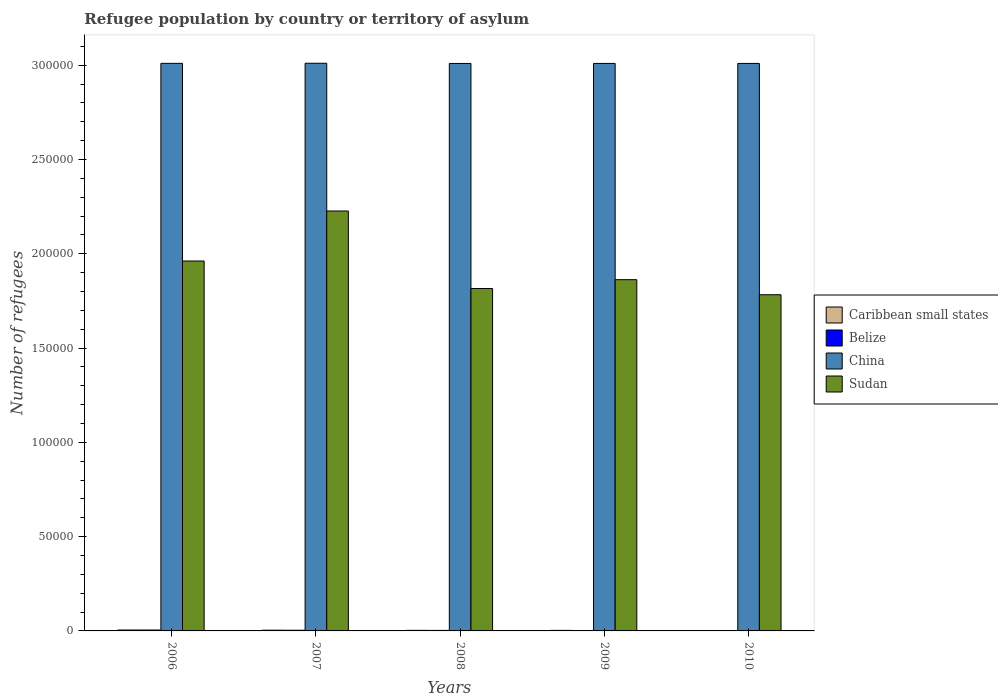How many different coloured bars are there?
Offer a very short reply. 4. Are the number of bars per tick equal to the number of legend labels?
Provide a succinct answer. Yes. Are the number of bars on each tick of the X-axis equal?
Give a very brief answer. Yes. How many bars are there on the 5th tick from the left?
Provide a succinct answer. 4. What is the number of refugees in China in 2006?
Your answer should be compact. 3.01e+05. Across all years, what is the maximum number of refugees in Caribbean small states?
Your answer should be compact. 488. Across all years, what is the minimum number of refugees in Belize?
Offer a very short reply. 134. In which year was the number of refugees in Belize maximum?
Ensure brevity in your answer.  2006. In which year was the number of refugees in China minimum?
Provide a short and direct response. 2008. What is the total number of refugees in China in the graph?
Provide a succinct answer. 1.51e+06. What is the difference between the number of refugees in Caribbean small states in 2007 and that in 2010?
Provide a short and direct response. 161. What is the difference between the number of refugees in China in 2009 and the number of refugees in Belize in 2006?
Offer a very short reply. 3.01e+05. What is the average number of refugees in China per year?
Provide a succinct answer. 3.01e+05. In the year 2006, what is the difference between the number of refugees in Belize and number of refugees in Sudan?
Your answer should be compact. -1.96e+05. In how many years, is the number of refugees in China greater than 290000?
Your answer should be very brief. 5. What is the ratio of the number of refugees in Belize in 2006 to that in 2010?
Give a very brief answer. 3.64. Is the number of refugees in China in 2006 less than that in 2010?
Your answer should be compact. No. What is the difference between the highest and the lowest number of refugees in Caribbean small states?
Your answer should be very brief. 268. Is it the case that in every year, the sum of the number of refugees in China and number of refugees in Caribbean small states is greater than the sum of number of refugees in Belize and number of refugees in Sudan?
Provide a short and direct response. No. What does the 2nd bar from the left in 2010 represents?
Provide a short and direct response. Belize. What does the 4th bar from the right in 2007 represents?
Keep it short and to the point. Caribbean small states. How many bars are there?
Give a very brief answer. 20. Are all the bars in the graph horizontal?
Your response must be concise. No. Does the graph contain grids?
Provide a succinct answer. No. Where does the legend appear in the graph?
Make the answer very short. Center right. How many legend labels are there?
Offer a terse response. 4. How are the legend labels stacked?
Offer a terse response. Vertical. What is the title of the graph?
Make the answer very short. Refugee population by country or territory of asylum. What is the label or title of the Y-axis?
Your answer should be compact. Number of refugees. What is the Number of refugees of Caribbean small states in 2006?
Ensure brevity in your answer.  488. What is the Number of refugees in Belize in 2006?
Offer a terse response. 488. What is the Number of refugees in China in 2006?
Offer a very short reply. 3.01e+05. What is the Number of refugees in Sudan in 2006?
Your answer should be very brief. 1.96e+05. What is the Number of refugees of Caribbean small states in 2007?
Offer a very short reply. 381. What is the Number of refugees of Belize in 2007?
Offer a terse response. 358. What is the Number of refugees in China in 2007?
Your response must be concise. 3.01e+05. What is the Number of refugees in Sudan in 2007?
Offer a terse response. 2.23e+05. What is the Number of refugees of Caribbean small states in 2008?
Keep it short and to the point. 311. What is the Number of refugees of Belize in 2008?
Your answer should be very brief. 277. What is the Number of refugees in China in 2008?
Offer a very short reply. 3.01e+05. What is the Number of refugees of Sudan in 2008?
Your answer should be very brief. 1.82e+05. What is the Number of refugees of Caribbean small states in 2009?
Ensure brevity in your answer.  294. What is the Number of refugees in Belize in 2009?
Provide a short and direct response. 230. What is the Number of refugees of China in 2009?
Your answer should be very brief. 3.01e+05. What is the Number of refugees of Sudan in 2009?
Keep it short and to the point. 1.86e+05. What is the Number of refugees in Caribbean small states in 2010?
Provide a succinct answer. 220. What is the Number of refugees of Belize in 2010?
Offer a terse response. 134. What is the Number of refugees in China in 2010?
Your answer should be compact. 3.01e+05. What is the Number of refugees of Sudan in 2010?
Give a very brief answer. 1.78e+05. Across all years, what is the maximum Number of refugees in Caribbean small states?
Your answer should be compact. 488. Across all years, what is the maximum Number of refugees in Belize?
Give a very brief answer. 488. Across all years, what is the maximum Number of refugees in China?
Provide a short and direct response. 3.01e+05. Across all years, what is the maximum Number of refugees in Sudan?
Provide a short and direct response. 2.23e+05. Across all years, what is the minimum Number of refugees in Caribbean small states?
Keep it short and to the point. 220. Across all years, what is the minimum Number of refugees of Belize?
Your response must be concise. 134. Across all years, what is the minimum Number of refugees in China?
Provide a succinct answer. 3.01e+05. Across all years, what is the minimum Number of refugees of Sudan?
Provide a short and direct response. 1.78e+05. What is the total Number of refugees in Caribbean small states in the graph?
Offer a terse response. 1694. What is the total Number of refugees in Belize in the graph?
Your answer should be very brief. 1487. What is the total Number of refugees of China in the graph?
Give a very brief answer. 1.51e+06. What is the total Number of refugees in Sudan in the graph?
Your answer should be very brief. 9.65e+05. What is the difference between the Number of refugees of Caribbean small states in 2006 and that in 2007?
Make the answer very short. 107. What is the difference between the Number of refugees in Belize in 2006 and that in 2007?
Provide a short and direct response. 130. What is the difference between the Number of refugees of China in 2006 and that in 2007?
Make the answer very short. -51. What is the difference between the Number of refugees of Sudan in 2006 and that in 2007?
Keep it short and to the point. -2.65e+04. What is the difference between the Number of refugees of Caribbean small states in 2006 and that in 2008?
Offer a terse response. 177. What is the difference between the Number of refugees in Belize in 2006 and that in 2008?
Offer a very short reply. 211. What is the difference between the Number of refugees in China in 2006 and that in 2008?
Provide a succinct answer. 60. What is the difference between the Number of refugees of Sudan in 2006 and that in 2008?
Provide a short and direct response. 1.46e+04. What is the difference between the Number of refugees in Caribbean small states in 2006 and that in 2009?
Provide a succinct answer. 194. What is the difference between the Number of refugees of Belize in 2006 and that in 2009?
Offer a terse response. 258. What is the difference between the Number of refugees in Sudan in 2006 and that in 2009?
Provide a succinct answer. 9908. What is the difference between the Number of refugees of Caribbean small states in 2006 and that in 2010?
Provide a succinct answer. 268. What is the difference between the Number of refugees of Belize in 2006 and that in 2010?
Make the answer very short. 354. What is the difference between the Number of refugees of Sudan in 2006 and that in 2010?
Keep it short and to the point. 1.79e+04. What is the difference between the Number of refugees in Caribbean small states in 2007 and that in 2008?
Offer a very short reply. 70. What is the difference between the Number of refugees of Belize in 2007 and that in 2008?
Give a very brief answer. 81. What is the difference between the Number of refugees in China in 2007 and that in 2008?
Your response must be concise. 111. What is the difference between the Number of refugees in Sudan in 2007 and that in 2008?
Provide a succinct answer. 4.11e+04. What is the difference between the Number of refugees of Caribbean small states in 2007 and that in 2009?
Offer a very short reply. 87. What is the difference between the Number of refugees of Belize in 2007 and that in 2009?
Provide a short and direct response. 128. What is the difference between the Number of refugees of China in 2007 and that in 2009?
Your answer should be compact. 89. What is the difference between the Number of refugees of Sudan in 2007 and that in 2009?
Keep it short and to the point. 3.64e+04. What is the difference between the Number of refugees of Caribbean small states in 2007 and that in 2010?
Offer a terse response. 161. What is the difference between the Number of refugees of Belize in 2007 and that in 2010?
Your answer should be very brief. 224. What is the difference between the Number of refugees of China in 2007 and that in 2010?
Your answer should be compact. 92. What is the difference between the Number of refugees in Sudan in 2007 and that in 2010?
Make the answer very short. 4.44e+04. What is the difference between the Number of refugees in Belize in 2008 and that in 2009?
Your answer should be compact. 47. What is the difference between the Number of refugees in China in 2008 and that in 2009?
Provide a succinct answer. -22. What is the difference between the Number of refugees of Sudan in 2008 and that in 2009?
Ensure brevity in your answer.  -4687. What is the difference between the Number of refugees in Caribbean small states in 2008 and that in 2010?
Offer a terse response. 91. What is the difference between the Number of refugees of Belize in 2008 and that in 2010?
Give a very brief answer. 143. What is the difference between the Number of refugees in Sudan in 2008 and that in 2010?
Your response must be concise. 3297. What is the difference between the Number of refugees of Belize in 2009 and that in 2010?
Offer a terse response. 96. What is the difference between the Number of refugees of Sudan in 2009 and that in 2010?
Offer a terse response. 7984. What is the difference between the Number of refugees of Caribbean small states in 2006 and the Number of refugees of Belize in 2007?
Provide a short and direct response. 130. What is the difference between the Number of refugees in Caribbean small states in 2006 and the Number of refugees in China in 2007?
Your answer should be compact. -3.01e+05. What is the difference between the Number of refugees of Caribbean small states in 2006 and the Number of refugees of Sudan in 2007?
Your response must be concise. -2.22e+05. What is the difference between the Number of refugees of Belize in 2006 and the Number of refugees of China in 2007?
Keep it short and to the point. -3.01e+05. What is the difference between the Number of refugees in Belize in 2006 and the Number of refugees in Sudan in 2007?
Your answer should be compact. -2.22e+05. What is the difference between the Number of refugees of China in 2006 and the Number of refugees of Sudan in 2007?
Your answer should be compact. 7.83e+04. What is the difference between the Number of refugees in Caribbean small states in 2006 and the Number of refugees in Belize in 2008?
Keep it short and to the point. 211. What is the difference between the Number of refugees in Caribbean small states in 2006 and the Number of refugees in China in 2008?
Ensure brevity in your answer.  -3.00e+05. What is the difference between the Number of refugees in Caribbean small states in 2006 and the Number of refugees in Sudan in 2008?
Ensure brevity in your answer.  -1.81e+05. What is the difference between the Number of refugees in Belize in 2006 and the Number of refugees in China in 2008?
Your response must be concise. -3.00e+05. What is the difference between the Number of refugees of Belize in 2006 and the Number of refugees of Sudan in 2008?
Keep it short and to the point. -1.81e+05. What is the difference between the Number of refugees of China in 2006 and the Number of refugees of Sudan in 2008?
Offer a terse response. 1.19e+05. What is the difference between the Number of refugees of Caribbean small states in 2006 and the Number of refugees of Belize in 2009?
Offer a terse response. 258. What is the difference between the Number of refugees in Caribbean small states in 2006 and the Number of refugees in China in 2009?
Your answer should be compact. -3.01e+05. What is the difference between the Number of refugees of Caribbean small states in 2006 and the Number of refugees of Sudan in 2009?
Ensure brevity in your answer.  -1.86e+05. What is the difference between the Number of refugees in Belize in 2006 and the Number of refugees in China in 2009?
Your answer should be very brief. -3.01e+05. What is the difference between the Number of refugees of Belize in 2006 and the Number of refugees of Sudan in 2009?
Ensure brevity in your answer.  -1.86e+05. What is the difference between the Number of refugees of China in 2006 and the Number of refugees of Sudan in 2009?
Your answer should be compact. 1.15e+05. What is the difference between the Number of refugees in Caribbean small states in 2006 and the Number of refugees in Belize in 2010?
Provide a succinct answer. 354. What is the difference between the Number of refugees in Caribbean small states in 2006 and the Number of refugees in China in 2010?
Ensure brevity in your answer.  -3.00e+05. What is the difference between the Number of refugees in Caribbean small states in 2006 and the Number of refugees in Sudan in 2010?
Keep it short and to the point. -1.78e+05. What is the difference between the Number of refugees of Belize in 2006 and the Number of refugees of China in 2010?
Offer a very short reply. -3.00e+05. What is the difference between the Number of refugees in Belize in 2006 and the Number of refugees in Sudan in 2010?
Keep it short and to the point. -1.78e+05. What is the difference between the Number of refugees of China in 2006 and the Number of refugees of Sudan in 2010?
Ensure brevity in your answer.  1.23e+05. What is the difference between the Number of refugees of Caribbean small states in 2007 and the Number of refugees of Belize in 2008?
Provide a short and direct response. 104. What is the difference between the Number of refugees in Caribbean small states in 2007 and the Number of refugees in China in 2008?
Your answer should be very brief. -3.01e+05. What is the difference between the Number of refugees in Caribbean small states in 2007 and the Number of refugees in Sudan in 2008?
Offer a terse response. -1.81e+05. What is the difference between the Number of refugees of Belize in 2007 and the Number of refugees of China in 2008?
Your answer should be compact. -3.01e+05. What is the difference between the Number of refugees of Belize in 2007 and the Number of refugees of Sudan in 2008?
Your answer should be very brief. -1.81e+05. What is the difference between the Number of refugees in China in 2007 and the Number of refugees in Sudan in 2008?
Your answer should be compact. 1.19e+05. What is the difference between the Number of refugees in Caribbean small states in 2007 and the Number of refugees in Belize in 2009?
Give a very brief answer. 151. What is the difference between the Number of refugees in Caribbean small states in 2007 and the Number of refugees in China in 2009?
Ensure brevity in your answer.  -3.01e+05. What is the difference between the Number of refugees of Caribbean small states in 2007 and the Number of refugees of Sudan in 2009?
Provide a succinct answer. -1.86e+05. What is the difference between the Number of refugees in Belize in 2007 and the Number of refugees in China in 2009?
Your answer should be very brief. -3.01e+05. What is the difference between the Number of refugees of Belize in 2007 and the Number of refugees of Sudan in 2009?
Provide a succinct answer. -1.86e+05. What is the difference between the Number of refugees in China in 2007 and the Number of refugees in Sudan in 2009?
Offer a very short reply. 1.15e+05. What is the difference between the Number of refugees of Caribbean small states in 2007 and the Number of refugees of Belize in 2010?
Offer a very short reply. 247. What is the difference between the Number of refugees in Caribbean small states in 2007 and the Number of refugees in China in 2010?
Provide a short and direct response. -3.01e+05. What is the difference between the Number of refugees in Caribbean small states in 2007 and the Number of refugees in Sudan in 2010?
Offer a terse response. -1.78e+05. What is the difference between the Number of refugees in Belize in 2007 and the Number of refugees in China in 2010?
Provide a short and direct response. -3.01e+05. What is the difference between the Number of refugees in Belize in 2007 and the Number of refugees in Sudan in 2010?
Give a very brief answer. -1.78e+05. What is the difference between the Number of refugees in China in 2007 and the Number of refugees in Sudan in 2010?
Give a very brief answer. 1.23e+05. What is the difference between the Number of refugees in Caribbean small states in 2008 and the Number of refugees in China in 2009?
Make the answer very short. -3.01e+05. What is the difference between the Number of refugees in Caribbean small states in 2008 and the Number of refugees in Sudan in 2009?
Offer a very short reply. -1.86e+05. What is the difference between the Number of refugees in Belize in 2008 and the Number of refugees in China in 2009?
Give a very brief answer. -3.01e+05. What is the difference between the Number of refugees of Belize in 2008 and the Number of refugees of Sudan in 2009?
Ensure brevity in your answer.  -1.86e+05. What is the difference between the Number of refugees in China in 2008 and the Number of refugees in Sudan in 2009?
Your answer should be very brief. 1.15e+05. What is the difference between the Number of refugees of Caribbean small states in 2008 and the Number of refugees of Belize in 2010?
Your response must be concise. 177. What is the difference between the Number of refugees of Caribbean small states in 2008 and the Number of refugees of China in 2010?
Provide a succinct answer. -3.01e+05. What is the difference between the Number of refugees in Caribbean small states in 2008 and the Number of refugees in Sudan in 2010?
Offer a terse response. -1.78e+05. What is the difference between the Number of refugees of Belize in 2008 and the Number of refugees of China in 2010?
Your answer should be compact. -3.01e+05. What is the difference between the Number of refugees of Belize in 2008 and the Number of refugees of Sudan in 2010?
Your answer should be very brief. -1.78e+05. What is the difference between the Number of refugees in China in 2008 and the Number of refugees in Sudan in 2010?
Offer a terse response. 1.23e+05. What is the difference between the Number of refugees in Caribbean small states in 2009 and the Number of refugees in Belize in 2010?
Provide a succinct answer. 160. What is the difference between the Number of refugees in Caribbean small states in 2009 and the Number of refugees in China in 2010?
Give a very brief answer. -3.01e+05. What is the difference between the Number of refugees in Caribbean small states in 2009 and the Number of refugees in Sudan in 2010?
Provide a short and direct response. -1.78e+05. What is the difference between the Number of refugees in Belize in 2009 and the Number of refugees in China in 2010?
Give a very brief answer. -3.01e+05. What is the difference between the Number of refugees of Belize in 2009 and the Number of refugees of Sudan in 2010?
Make the answer very short. -1.78e+05. What is the difference between the Number of refugees in China in 2009 and the Number of refugees in Sudan in 2010?
Provide a succinct answer. 1.23e+05. What is the average Number of refugees in Caribbean small states per year?
Make the answer very short. 338.8. What is the average Number of refugees in Belize per year?
Ensure brevity in your answer.  297.4. What is the average Number of refugees of China per year?
Give a very brief answer. 3.01e+05. What is the average Number of refugees in Sudan per year?
Your answer should be compact. 1.93e+05. In the year 2006, what is the difference between the Number of refugees of Caribbean small states and Number of refugees of China?
Provide a short and direct response. -3.01e+05. In the year 2006, what is the difference between the Number of refugees of Caribbean small states and Number of refugees of Sudan?
Keep it short and to the point. -1.96e+05. In the year 2006, what is the difference between the Number of refugees of Belize and Number of refugees of China?
Make the answer very short. -3.01e+05. In the year 2006, what is the difference between the Number of refugees in Belize and Number of refugees in Sudan?
Provide a succinct answer. -1.96e+05. In the year 2006, what is the difference between the Number of refugees in China and Number of refugees in Sudan?
Offer a very short reply. 1.05e+05. In the year 2007, what is the difference between the Number of refugees in Caribbean small states and Number of refugees in Belize?
Your answer should be very brief. 23. In the year 2007, what is the difference between the Number of refugees in Caribbean small states and Number of refugees in China?
Keep it short and to the point. -3.01e+05. In the year 2007, what is the difference between the Number of refugees of Caribbean small states and Number of refugees of Sudan?
Make the answer very short. -2.22e+05. In the year 2007, what is the difference between the Number of refugees of Belize and Number of refugees of China?
Your response must be concise. -3.01e+05. In the year 2007, what is the difference between the Number of refugees in Belize and Number of refugees in Sudan?
Your answer should be compact. -2.22e+05. In the year 2007, what is the difference between the Number of refugees of China and Number of refugees of Sudan?
Provide a short and direct response. 7.84e+04. In the year 2008, what is the difference between the Number of refugees in Caribbean small states and Number of refugees in Belize?
Keep it short and to the point. 34. In the year 2008, what is the difference between the Number of refugees in Caribbean small states and Number of refugees in China?
Your response must be concise. -3.01e+05. In the year 2008, what is the difference between the Number of refugees of Caribbean small states and Number of refugees of Sudan?
Provide a short and direct response. -1.81e+05. In the year 2008, what is the difference between the Number of refugees in Belize and Number of refugees in China?
Your answer should be very brief. -3.01e+05. In the year 2008, what is the difference between the Number of refugees in Belize and Number of refugees in Sudan?
Keep it short and to the point. -1.81e+05. In the year 2008, what is the difference between the Number of refugees of China and Number of refugees of Sudan?
Give a very brief answer. 1.19e+05. In the year 2009, what is the difference between the Number of refugees of Caribbean small states and Number of refugees of Belize?
Your answer should be compact. 64. In the year 2009, what is the difference between the Number of refugees in Caribbean small states and Number of refugees in China?
Offer a terse response. -3.01e+05. In the year 2009, what is the difference between the Number of refugees of Caribbean small states and Number of refugees of Sudan?
Provide a succinct answer. -1.86e+05. In the year 2009, what is the difference between the Number of refugees in Belize and Number of refugees in China?
Your answer should be compact. -3.01e+05. In the year 2009, what is the difference between the Number of refugees in Belize and Number of refugees in Sudan?
Your answer should be compact. -1.86e+05. In the year 2009, what is the difference between the Number of refugees of China and Number of refugees of Sudan?
Your response must be concise. 1.15e+05. In the year 2010, what is the difference between the Number of refugees in Caribbean small states and Number of refugees in Belize?
Give a very brief answer. 86. In the year 2010, what is the difference between the Number of refugees of Caribbean small states and Number of refugees of China?
Provide a succinct answer. -3.01e+05. In the year 2010, what is the difference between the Number of refugees in Caribbean small states and Number of refugees in Sudan?
Offer a very short reply. -1.78e+05. In the year 2010, what is the difference between the Number of refugees in Belize and Number of refugees in China?
Ensure brevity in your answer.  -3.01e+05. In the year 2010, what is the difference between the Number of refugees of Belize and Number of refugees of Sudan?
Offer a terse response. -1.78e+05. In the year 2010, what is the difference between the Number of refugees in China and Number of refugees in Sudan?
Give a very brief answer. 1.23e+05. What is the ratio of the Number of refugees in Caribbean small states in 2006 to that in 2007?
Offer a terse response. 1.28. What is the ratio of the Number of refugees in Belize in 2006 to that in 2007?
Your answer should be very brief. 1.36. What is the ratio of the Number of refugees of China in 2006 to that in 2007?
Ensure brevity in your answer.  1. What is the ratio of the Number of refugees of Sudan in 2006 to that in 2007?
Keep it short and to the point. 0.88. What is the ratio of the Number of refugees of Caribbean small states in 2006 to that in 2008?
Provide a succinct answer. 1.57. What is the ratio of the Number of refugees in Belize in 2006 to that in 2008?
Ensure brevity in your answer.  1.76. What is the ratio of the Number of refugees of China in 2006 to that in 2008?
Offer a terse response. 1. What is the ratio of the Number of refugees of Sudan in 2006 to that in 2008?
Ensure brevity in your answer.  1.08. What is the ratio of the Number of refugees of Caribbean small states in 2006 to that in 2009?
Make the answer very short. 1.66. What is the ratio of the Number of refugees of Belize in 2006 to that in 2009?
Give a very brief answer. 2.12. What is the ratio of the Number of refugees in Sudan in 2006 to that in 2009?
Keep it short and to the point. 1.05. What is the ratio of the Number of refugees of Caribbean small states in 2006 to that in 2010?
Keep it short and to the point. 2.22. What is the ratio of the Number of refugees of Belize in 2006 to that in 2010?
Provide a succinct answer. 3.64. What is the ratio of the Number of refugees of Sudan in 2006 to that in 2010?
Provide a succinct answer. 1.1. What is the ratio of the Number of refugees of Caribbean small states in 2007 to that in 2008?
Offer a terse response. 1.23. What is the ratio of the Number of refugees of Belize in 2007 to that in 2008?
Your answer should be compact. 1.29. What is the ratio of the Number of refugees of China in 2007 to that in 2008?
Offer a terse response. 1. What is the ratio of the Number of refugees in Sudan in 2007 to that in 2008?
Offer a terse response. 1.23. What is the ratio of the Number of refugees in Caribbean small states in 2007 to that in 2009?
Provide a succinct answer. 1.3. What is the ratio of the Number of refugees of Belize in 2007 to that in 2009?
Keep it short and to the point. 1.56. What is the ratio of the Number of refugees in China in 2007 to that in 2009?
Keep it short and to the point. 1. What is the ratio of the Number of refugees in Sudan in 2007 to that in 2009?
Give a very brief answer. 1.2. What is the ratio of the Number of refugees of Caribbean small states in 2007 to that in 2010?
Offer a very short reply. 1.73. What is the ratio of the Number of refugees of Belize in 2007 to that in 2010?
Offer a terse response. 2.67. What is the ratio of the Number of refugees in China in 2007 to that in 2010?
Give a very brief answer. 1. What is the ratio of the Number of refugees in Sudan in 2007 to that in 2010?
Your answer should be very brief. 1.25. What is the ratio of the Number of refugees in Caribbean small states in 2008 to that in 2009?
Your answer should be very brief. 1.06. What is the ratio of the Number of refugees in Belize in 2008 to that in 2009?
Provide a short and direct response. 1.2. What is the ratio of the Number of refugees of China in 2008 to that in 2009?
Your response must be concise. 1. What is the ratio of the Number of refugees of Sudan in 2008 to that in 2009?
Your answer should be compact. 0.97. What is the ratio of the Number of refugees in Caribbean small states in 2008 to that in 2010?
Your answer should be compact. 1.41. What is the ratio of the Number of refugees of Belize in 2008 to that in 2010?
Keep it short and to the point. 2.07. What is the ratio of the Number of refugees in Sudan in 2008 to that in 2010?
Your response must be concise. 1.02. What is the ratio of the Number of refugees in Caribbean small states in 2009 to that in 2010?
Your answer should be compact. 1.34. What is the ratio of the Number of refugees of Belize in 2009 to that in 2010?
Provide a short and direct response. 1.72. What is the ratio of the Number of refugees of China in 2009 to that in 2010?
Provide a succinct answer. 1. What is the ratio of the Number of refugees of Sudan in 2009 to that in 2010?
Keep it short and to the point. 1.04. What is the difference between the highest and the second highest Number of refugees of Caribbean small states?
Your response must be concise. 107. What is the difference between the highest and the second highest Number of refugees of Belize?
Provide a succinct answer. 130. What is the difference between the highest and the second highest Number of refugees of Sudan?
Your answer should be compact. 2.65e+04. What is the difference between the highest and the lowest Number of refugees in Caribbean small states?
Your answer should be very brief. 268. What is the difference between the highest and the lowest Number of refugees in Belize?
Make the answer very short. 354. What is the difference between the highest and the lowest Number of refugees of China?
Give a very brief answer. 111. What is the difference between the highest and the lowest Number of refugees in Sudan?
Provide a short and direct response. 4.44e+04. 